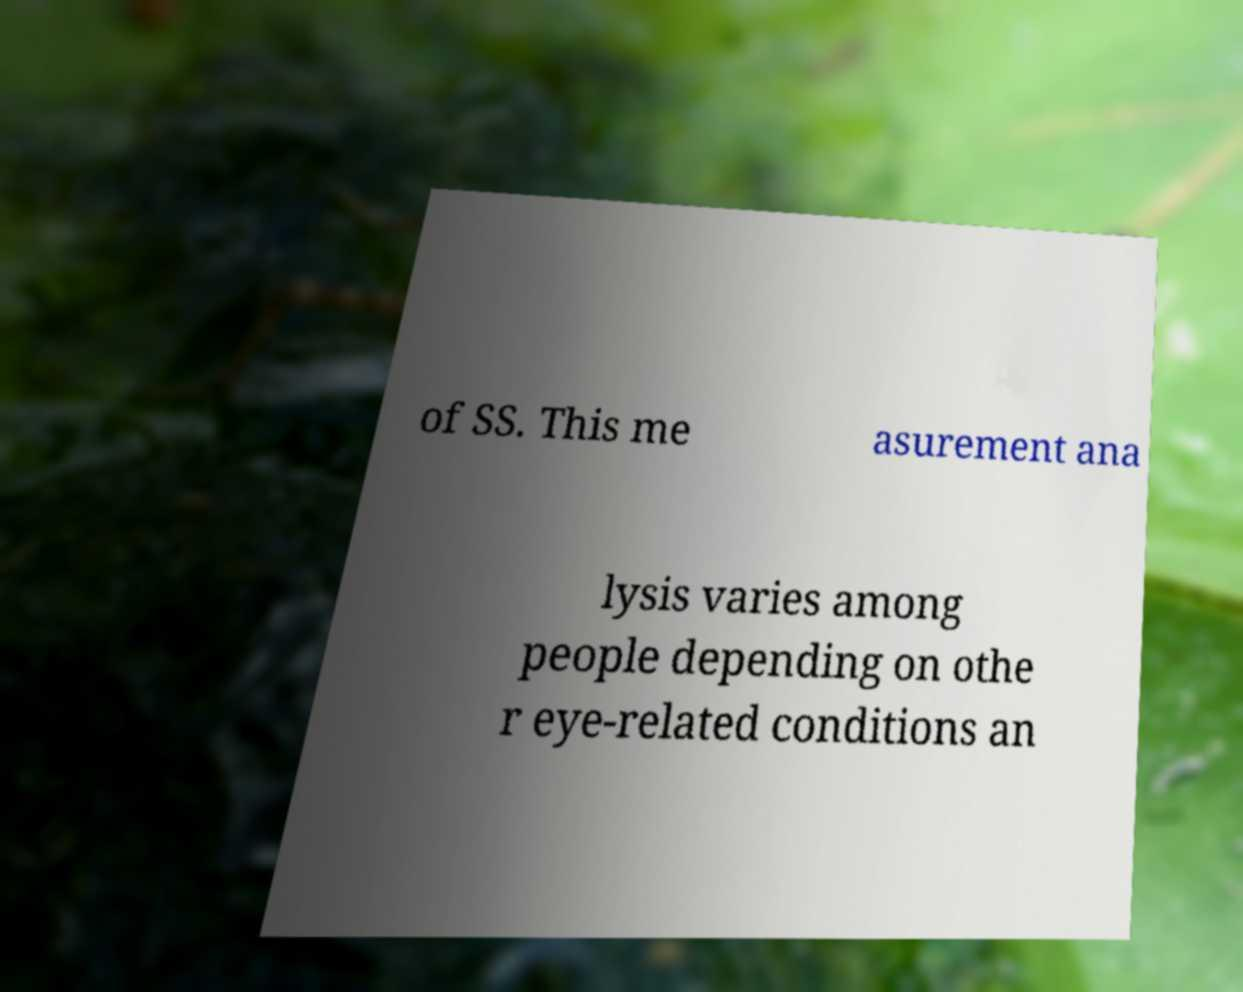Please read and relay the text visible in this image. What does it say? of SS. This me asurement ana lysis varies among people depending on othe r eye-related conditions an 